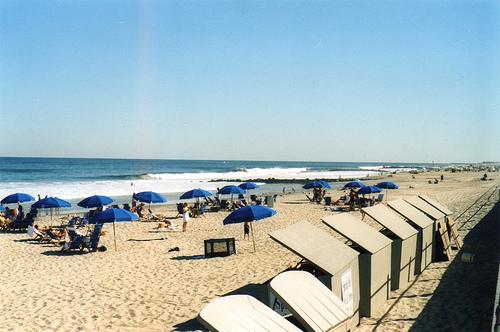How many umbrellas are there?
Give a very brief answer. 13. Where would a person sit to get out of the direct sunlight?
Quick response, please. Under umbrella. What color are the umbrellas?
Short answer required. Blue. 